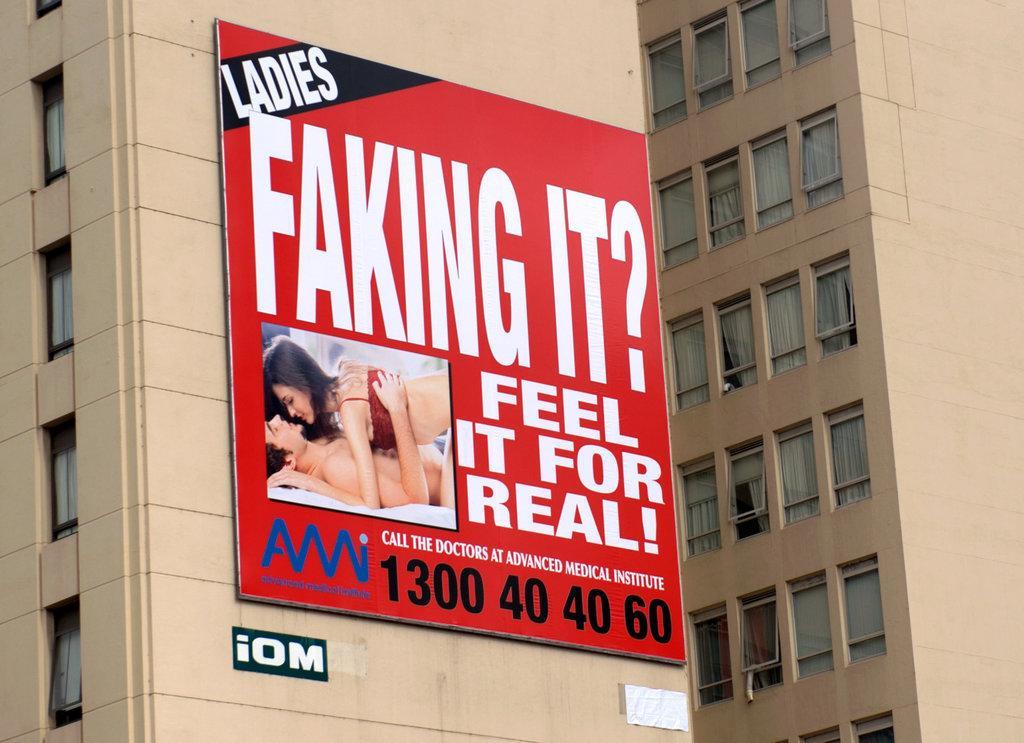Can you describe this image briefly? In this image we can see an advertisement on the walls of a building. 